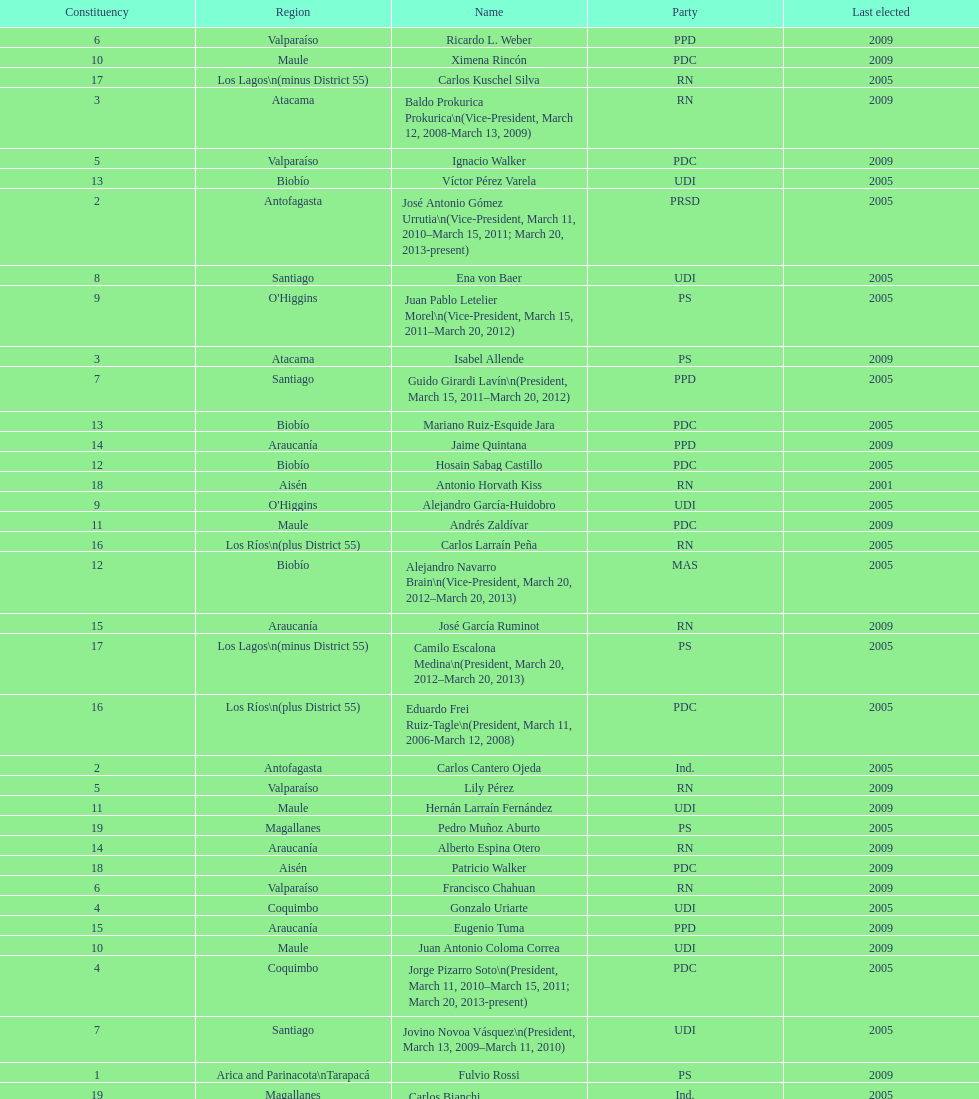Who was not last elected in either 2005 or 2009? Antonio Horvath Kiss. 